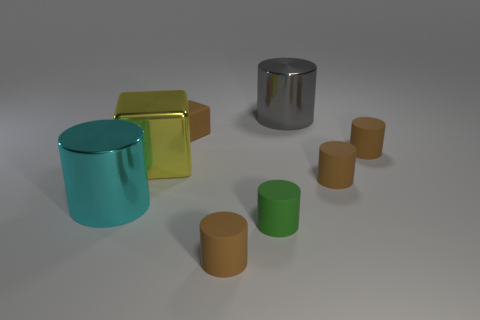What number of other objects are the same size as the green rubber cylinder?
Make the answer very short. 4. What is the brown block made of?
Provide a short and direct response. Rubber. What is the material of the big thing that is in front of the yellow block?
Make the answer very short. Metal. Is there any other thing that has the same material as the gray object?
Provide a short and direct response. Yes. Is the number of small cylinders that are to the right of the big gray shiny object greater than the number of yellow things?
Your answer should be very brief. Yes. Are there any large cyan metal objects to the right of the large yellow cube that is on the right side of the large cylinder that is to the left of the large gray metallic cylinder?
Your answer should be very brief. No. Are there any brown cylinders left of the large metallic block?
Give a very brief answer. No. What number of matte cylinders are the same color as the large shiny cube?
Your answer should be very brief. 0. There is a gray thing that is made of the same material as the cyan object; what is its size?
Your response must be concise. Large. There is a rubber thing on the left side of the object in front of the green object to the right of the brown block; what size is it?
Ensure brevity in your answer.  Small. 